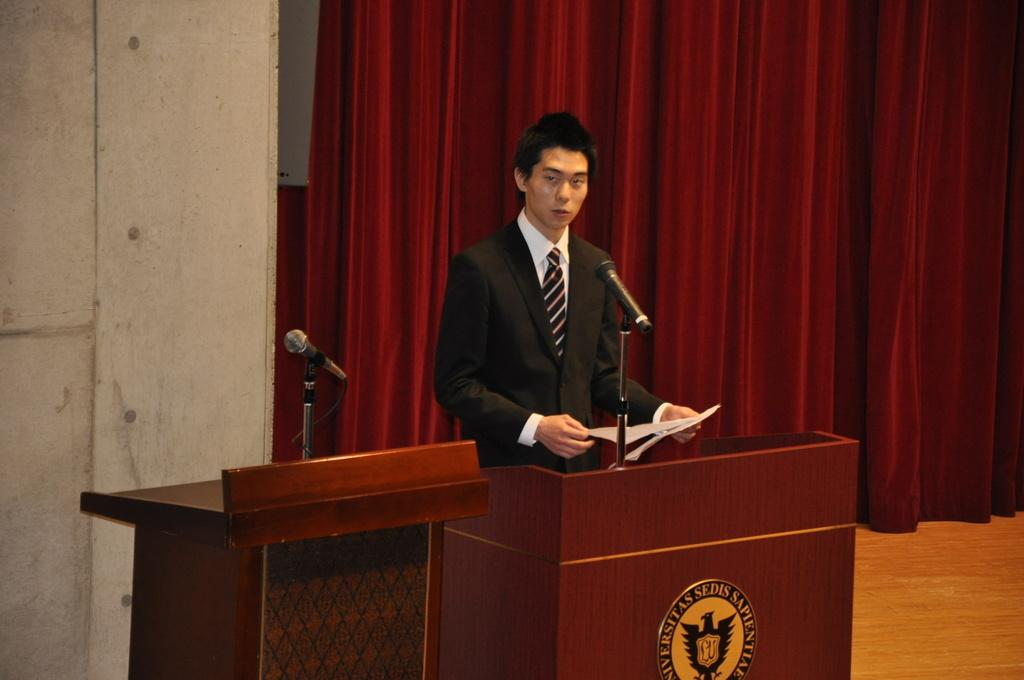What is the person in the image doing? The person is holding a paper. What is the person wearing in the image? The person is wearing a black and white dress. What objects are in front of the person in the image? There are two microphones and podiums in front of the person. What can be seen behind the person in the image? There is a maroon-colored curtain behind the person. What type of downtown area can be seen in the image? There is no downtown area present in the image; it features a person holding a paper, wearing a black and white dress, and standing in front of microphones, podiums, and a maroon-colored curtain. Can you tell me what type of spade the person is using in the image? There is no spade present in the image; the person is holding a paper and standing in front of microphones, podiums, and a maroon-colored curtain. 